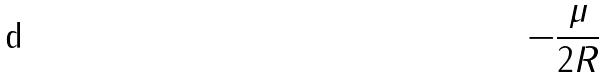Convert formula to latex. <formula><loc_0><loc_0><loc_500><loc_500>- \frac { \mu } { 2 R }</formula> 